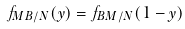<formula> <loc_0><loc_0><loc_500><loc_500>f _ { M B / N } ( y ) = f _ { B M / N } ( 1 - y )</formula> 